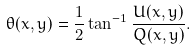Convert formula to latex. <formula><loc_0><loc_0><loc_500><loc_500>\theta ( x , y ) = \frac { 1 } { 2 } \tan ^ { - 1 } \frac { U ( x , y ) } { Q ( x , y ) } .</formula> 